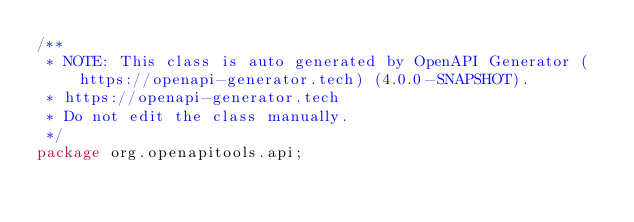Convert code to text. <code><loc_0><loc_0><loc_500><loc_500><_Java_>/**
 * NOTE: This class is auto generated by OpenAPI Generator (https://openapi-generator.tech) (4.0.0-SNAPSHOT).
 * https://openapi-generator.tech
 * Do not edit the class manually.
 */
package org.openapitools.api;
</code> 